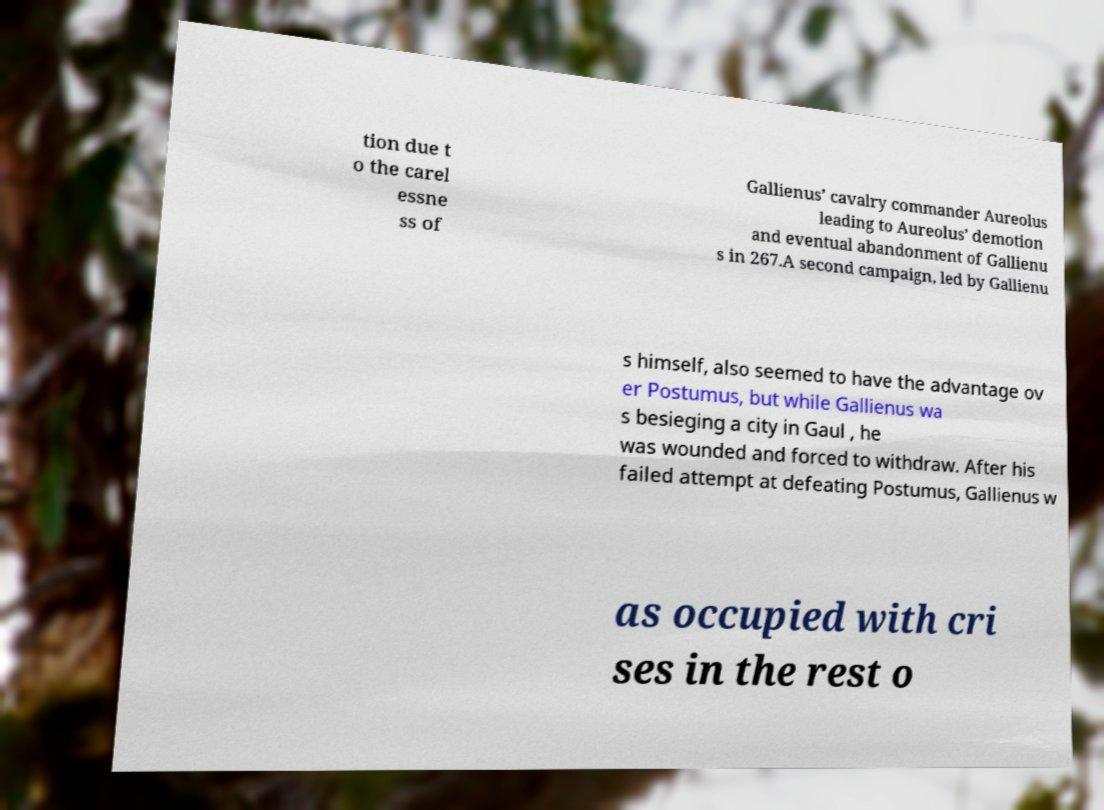What messages or text are displayed in this image? I need them in a readable, typed format. tion due t o the carel essne ss of Gallienus’ cavalry commander Aureolus leading to Aureolus’ demotion and eventual abandonment of Gallienu s in 267.A second campaign, led by Gallienu s himself, also seemed to have the advantage ov er Postumus, but while Gallienus wa s besieging a city in Gaul , he was wounded and forced to withdraw. After his failed attempt at defeating Postumus, Gallienus w as occupied with cri ses in the rest o 